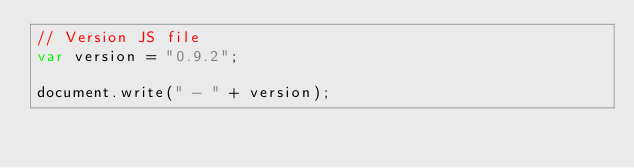<code> <loc_0><loc_0><loc_500><loc_500><_JavaScript_>// Version JS file
var version = "0.9.2";

document.write(" - " + version);
</code> 